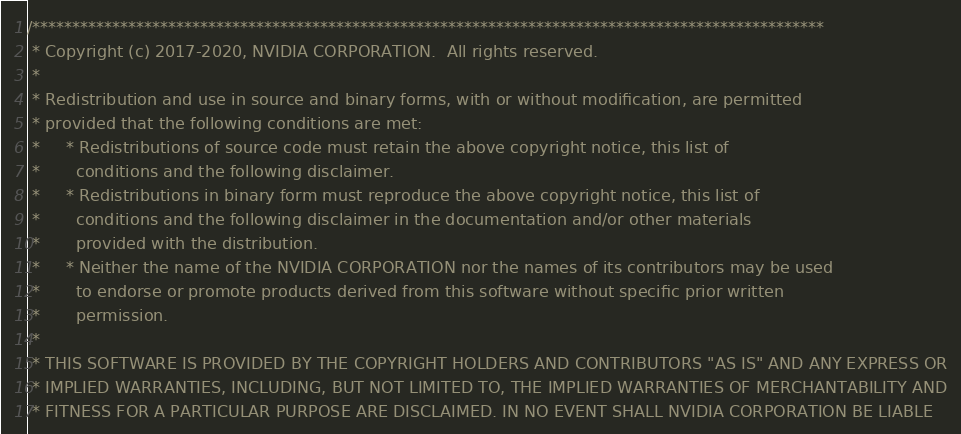<code> <loc_0><loc_0><loc_500><loc_500><_Cuda_>/***************************************************************************************************
 * Copyright (c) 2017-2020, NVIDIA CORPORATION.  All rights reserved.
 *
 * Redistribution and use in source and binary forms, with or without modification, are permitted
 * provided that the following conditions are met:
 *     * Redistributions of source code must retain the above copyright notice, this list of
 *       conditions and the following disclaimer.
 *     * Redistributions in binary form must reproduce the above copyright notice, this list of
 *       conditions and the following disclaimer in the documentation and/or other materials
 *       provided with the distribution.
 *     * Neither the name of the NVIDIA CORPORATION nor the names of its contributors may be used
 *       to endorse or promote products derived from this software without specific prior written
 *       permission.
 *
 * THIS SOFTWARE IS PROVIDED BY THE COPYRIGHT HOLDERS AND CONTRIBUTORS "AS IS" AND ANY EXPRESS OR
 * IMPLIED WARRANTIES, INCLUDING, BUT NOT LIMITED TO, THE IMPLIED WARRANTIES OF MERCHANTABILITY AND
 * FITNESS FOR A PARTICULAR PURPOSE ARE DISCLAIMED. IN NO EVENT SHALL NVIDIA CORPORATION BE LIABLE</code> 